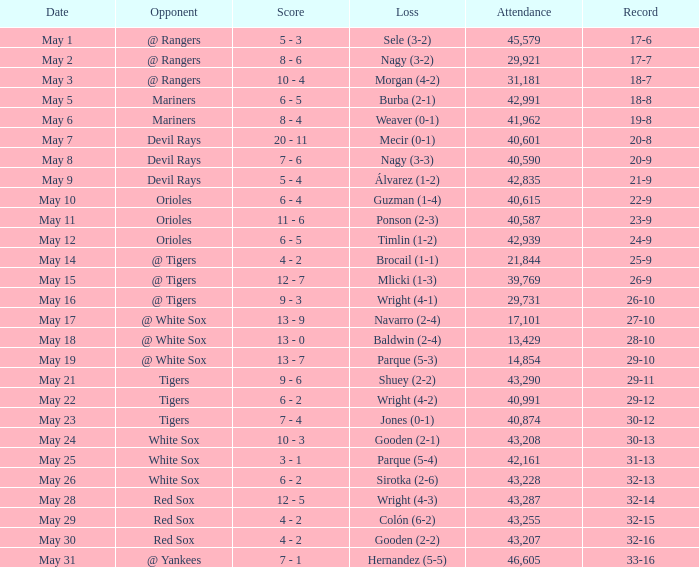What loss has 26-9 as a loss? Mlicki (1-3). 